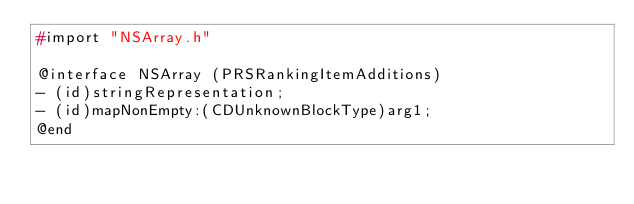Convert code to text. <code><loc_0><loc_0><loc_500><loc_500><_C_>#import "NSArray.h"

@interface NSArray (PRSRankingItemAdditions)
- (id)stringRepresentation;
- (id)mapNonEmpty:(CDUnknownBlockType)arg1;
@end

</code> 